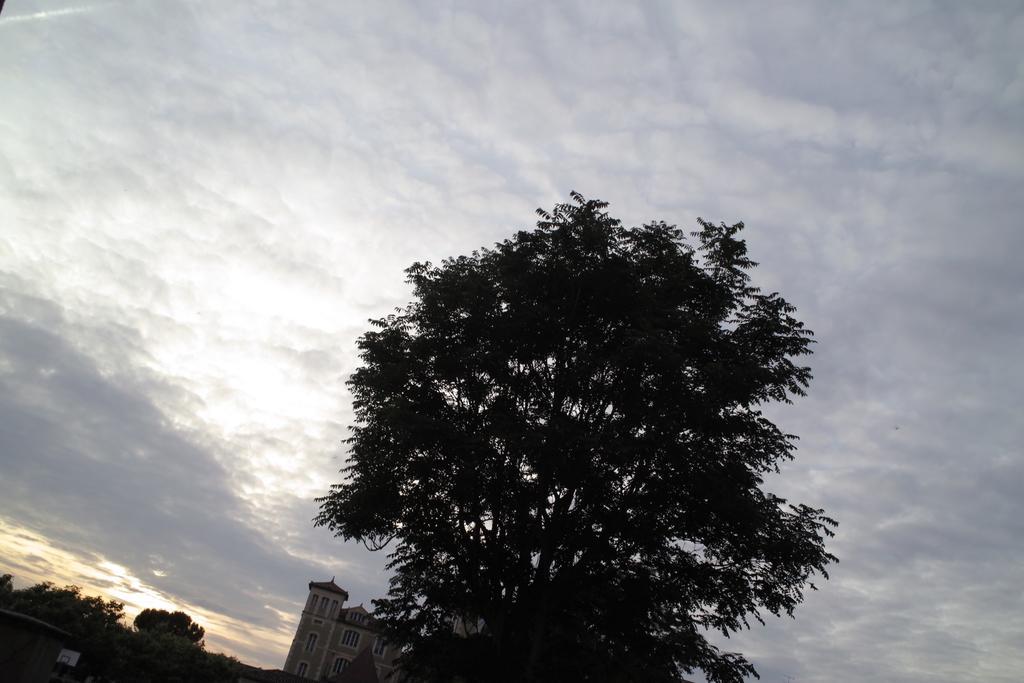In one or two sentences, can you explain what this image depicts? In the middle of the picture, we see a tree and in the left bottom of the picture, there are trees and a building in white color. At the top of the picture, we see the sky. 